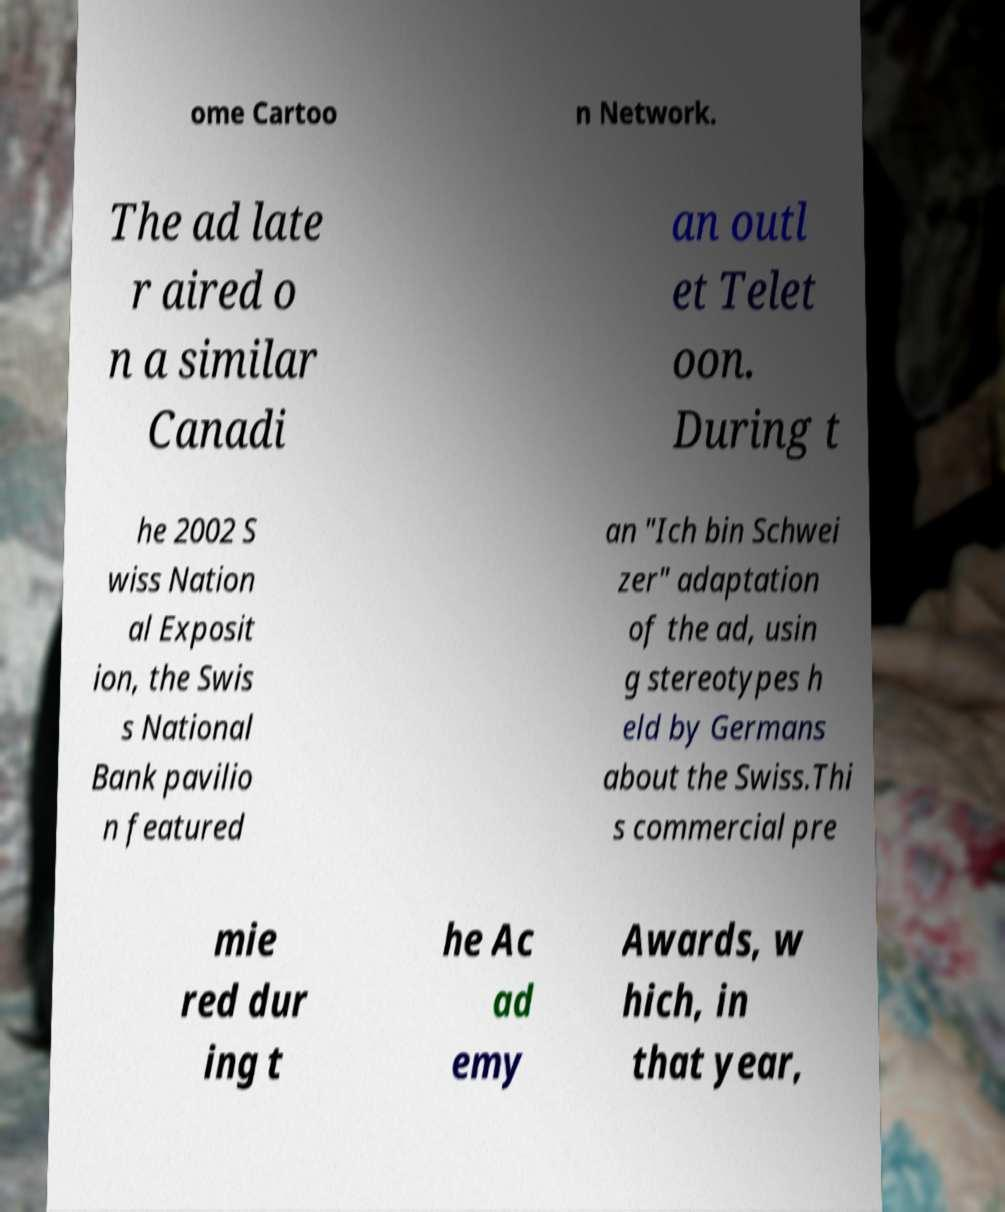Please identify and transcribe the text found in this image. ome Cartoo n Network. The ad late r aired o n a similar Canadi an outl et Telet oon. During t he 2002 S wiss Nation al Exposit ion, the Swis s National Bank pavilio n featured an "Ich bin Schwei zer" adaptation of the ad, usin g stereotypes h eld by Germans about the Swiss.Thi s commercial pre mie red dur ing t he Ac ad emy Awards, w hich, in that year, 